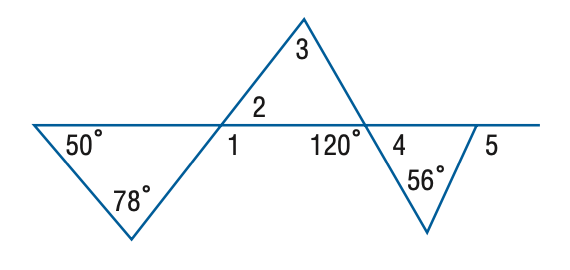Answer the mathemtical geometry problem and directly provide the correct option letter.
Question: Find the measure of \angle 4 in the figure.
Choices: A: 52 B: 56 C: 58 D: 60 D 